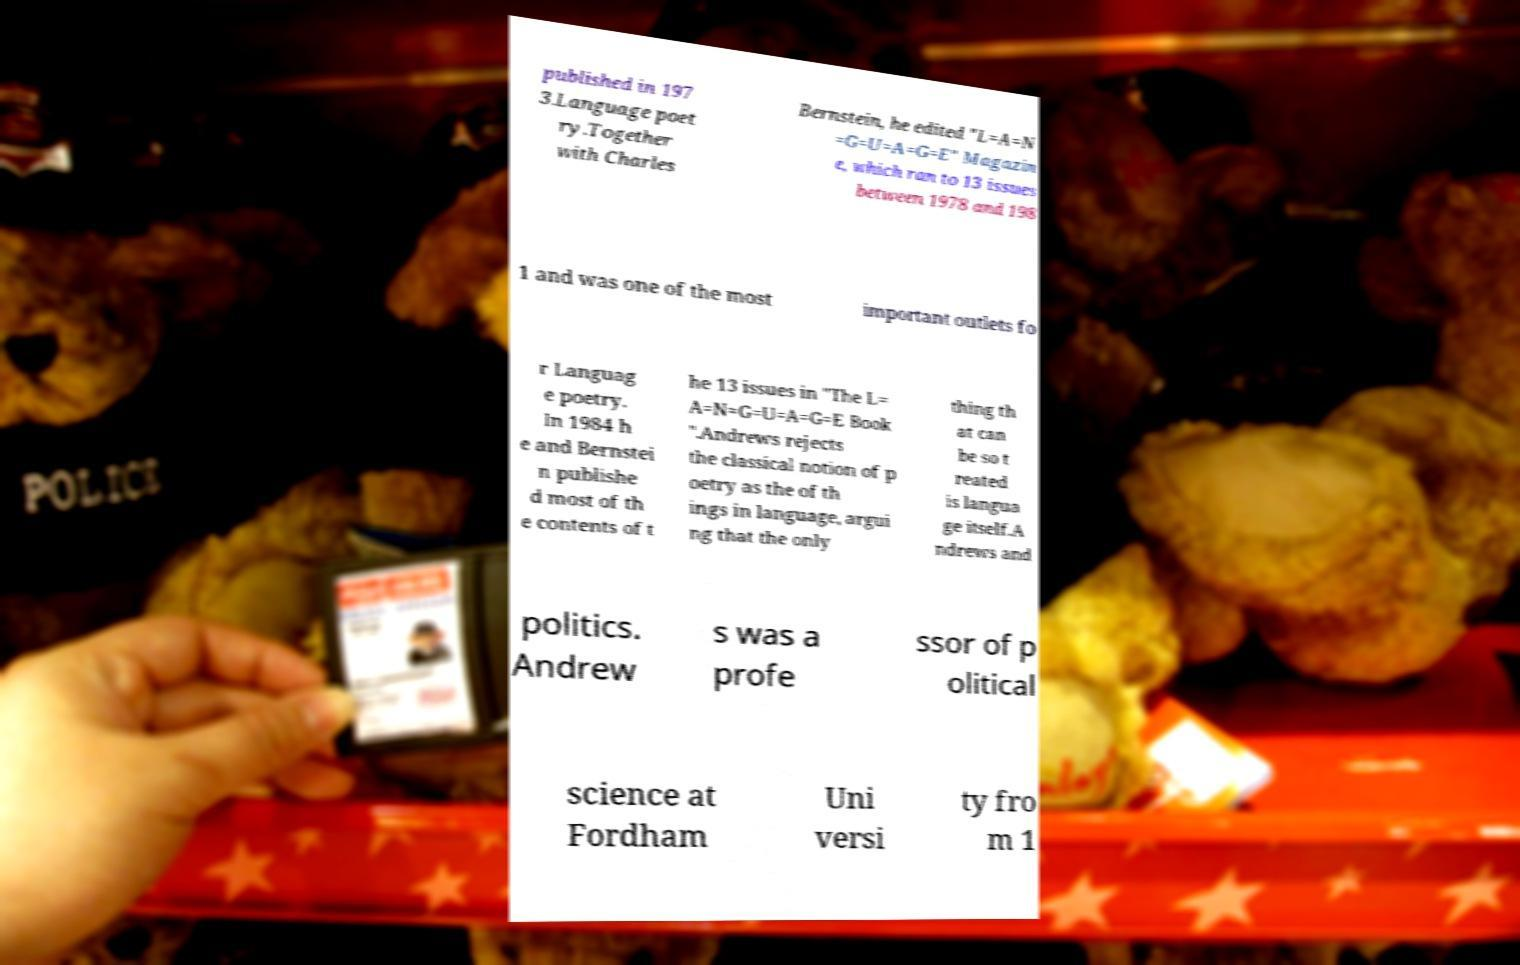What messages or text are displayed in this image? I need them in a readable, typed format. published in 197 3.Language poet ry.Together with Charles Bernstein, he edited "L=A=N =G=U=A=G=E" Magazin e, which ran to 13 issues between 1978 and 198 1 and was one of the most important outlets fo r Languag e poetry. In 1984 h e and Bernstei n publishe d most of th e contents of t he 13 issues in "The L= A=N=G=U=A=G=E Book ".Andrews rejects the classical notion of p oetry as the of th ings in language, argui ng that the only thing th at can be so t reated is langua ge itself.A ndrews and politics. Andrew s was a profe ssor of p olitical science at Fordham Uni versi ty fro m 1 